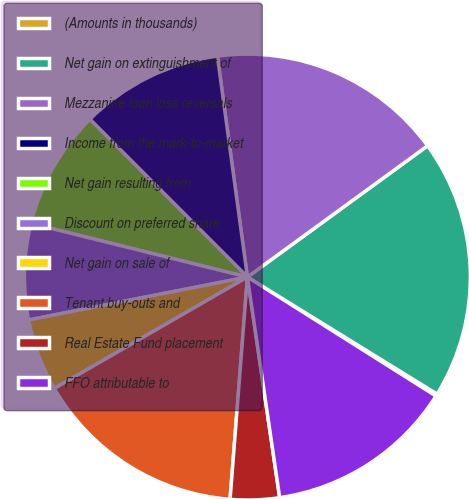Convert chart to OTSL. <chart><loc_0><loc_0><loc_500><loc_500><pie_chart><fcel>(Amounts in thousands)<fcel>Net gain on extinguishment of<fcel>Mezzanine loan loss reversals<fcel>Income from the mark-to-market<fcel>Net gain resulting from<fcel>Discount on preferred share<fcel>Net gain on sale of<fcel>Tenant buy-outs and<fcel>Real Estate Fund placement<fcel>FFO attributable to<nl><fcel>0.16%<fcel>18.82%<fcel>17.13%<fcel>10.34%<fcel>8.64%<fcel>6.95%<fcel>5.25%<fcel>15.43%<fcel>3.55%<fcel>13.73%<nl></chart> 